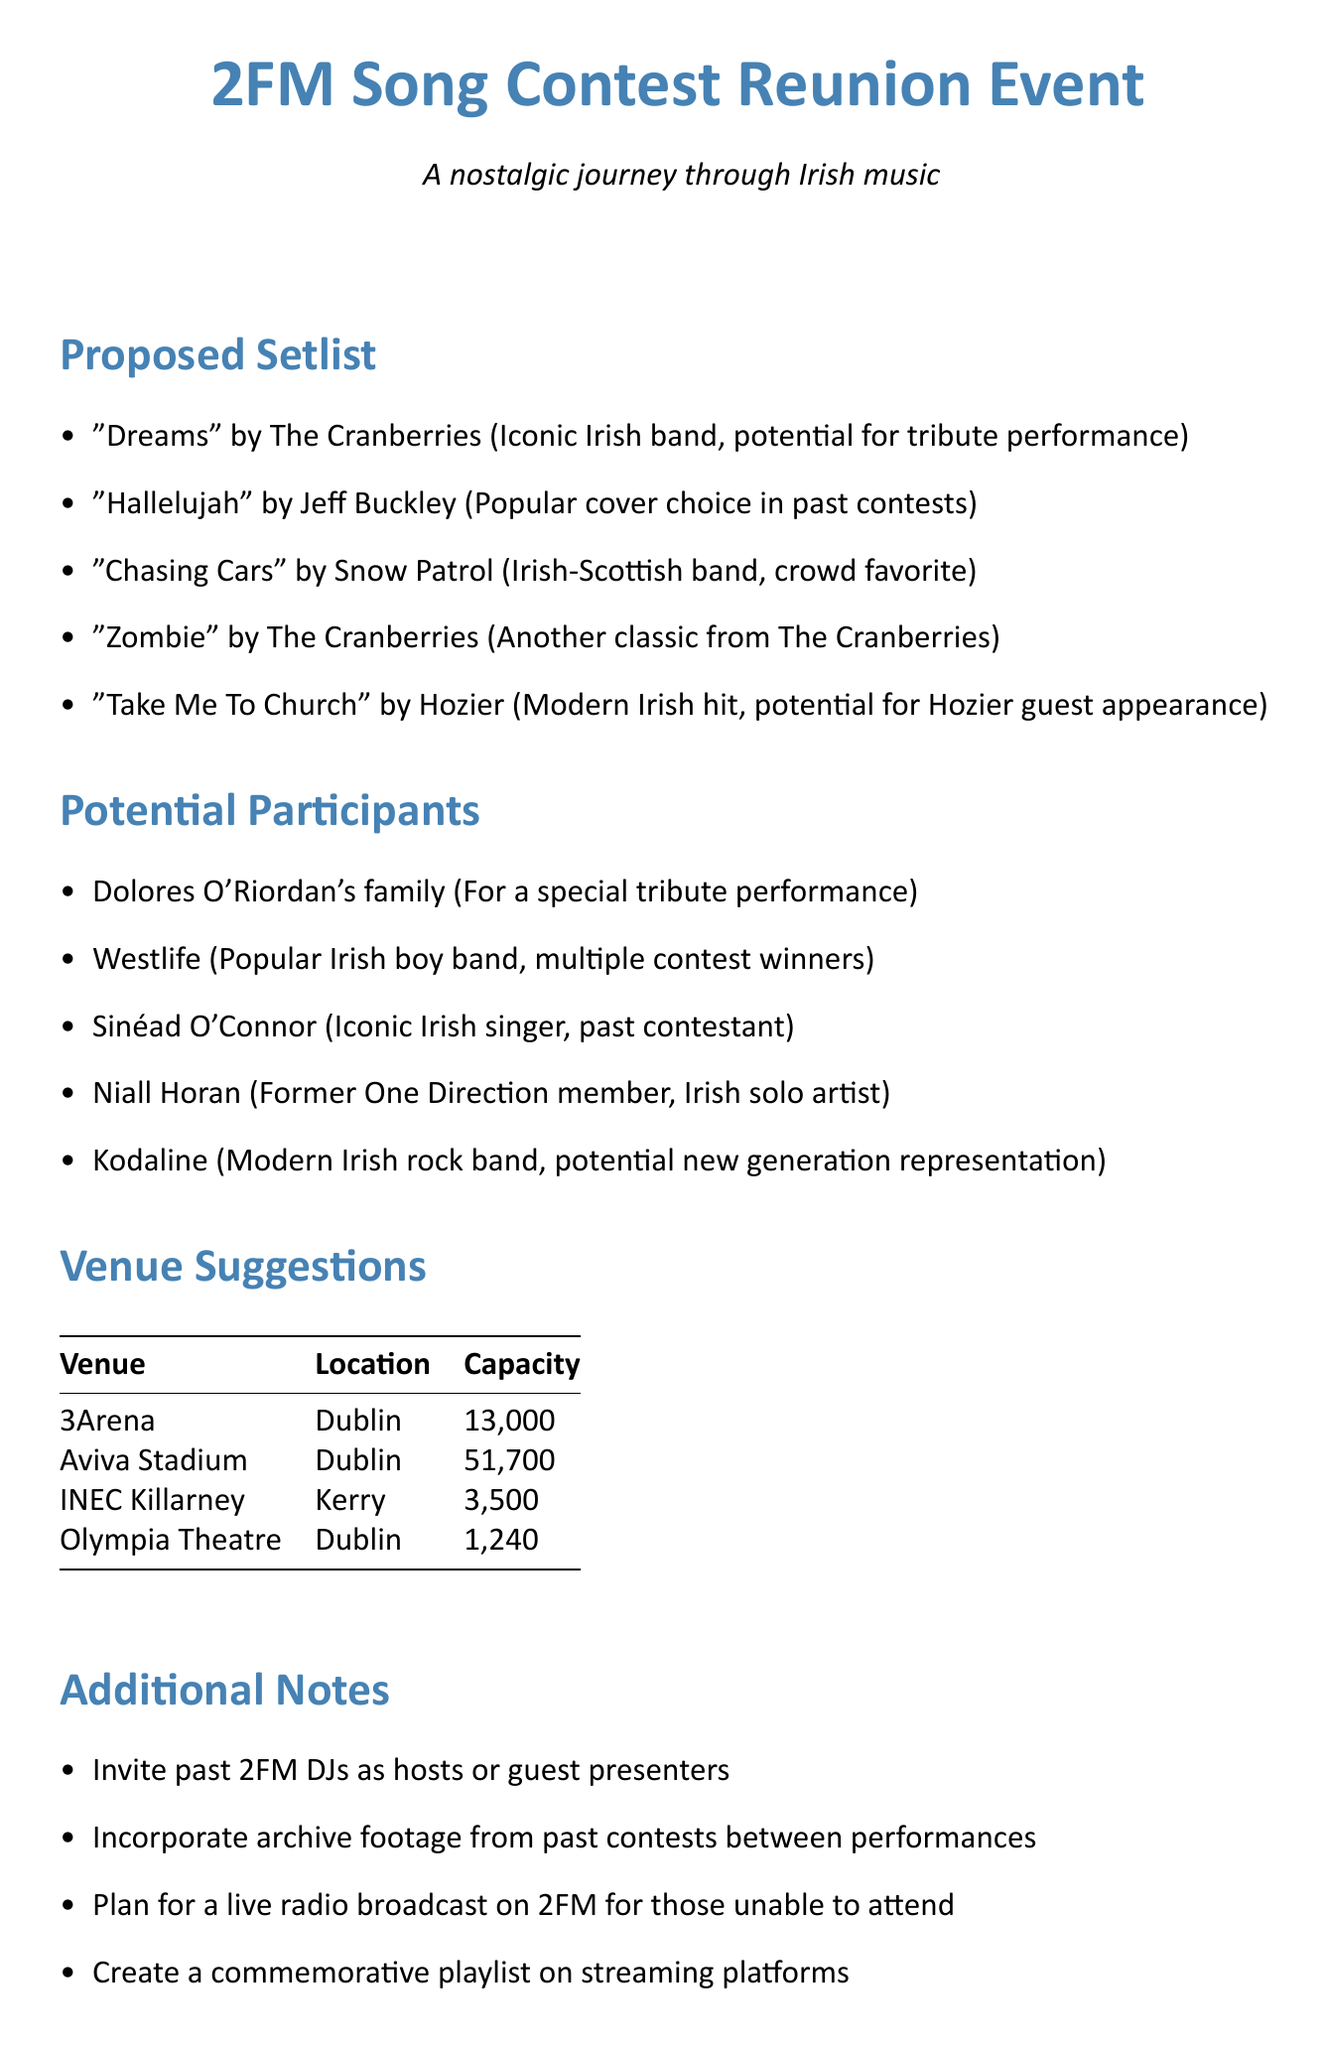What is the first song listed in the proposed setlist? The first song listed in the proposed setlist is "Dreams" by The Cranberries.
Answer: "Dreams" Who is noted for a special tribute performance? Dolores O'Riordan's family is noted for a special tribute performance.
Answer: Dolores O'Riordan's family What is the capacity of the Aviva Stadium? The capacity of the Aviva Stadium is noted in the document as 51,700.
Answer: 51,700 Which artist is suggested for a potential guest appearance? Hozier is suggested for a potential guest appearance.
Answer: Hozier How many potential participants are listed in the memo? The number of potential participants listed is five.
Answer: Five What is the location of the INEC Killarney? The location of INEC Killarney is noted as Kerry.
Answer: Kerry What kind of performances are mentioned for the Olympia Theatre? The document mentions the Olympia Theatre for intimate acoustic performances.
Answer: Acoustic performances Which song is a popular cover choice in past contests? "Hallelujah" by Jeff Buckley is described as a popular cover choice in past contests.
Answer: "Hallelujah" What additional note suggests a digital component for the event? The document notes to create a commemorative playlist on streaming platforms.
Answer: Commemorative playlist 